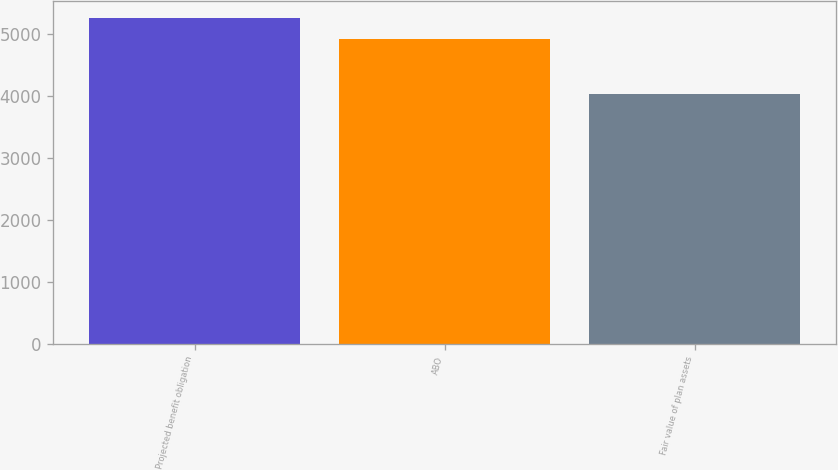Convert chart to OTSL. <chart><loc_0><loc_0><loc_500><loc_500><bar_chart><fcel>Projected benefit obligation<fcel>ABO<fcel>Fair value of plan assets<nl><fcel>5270.6<fcel>4920.5<fcel>4044.2<nl></chart> 